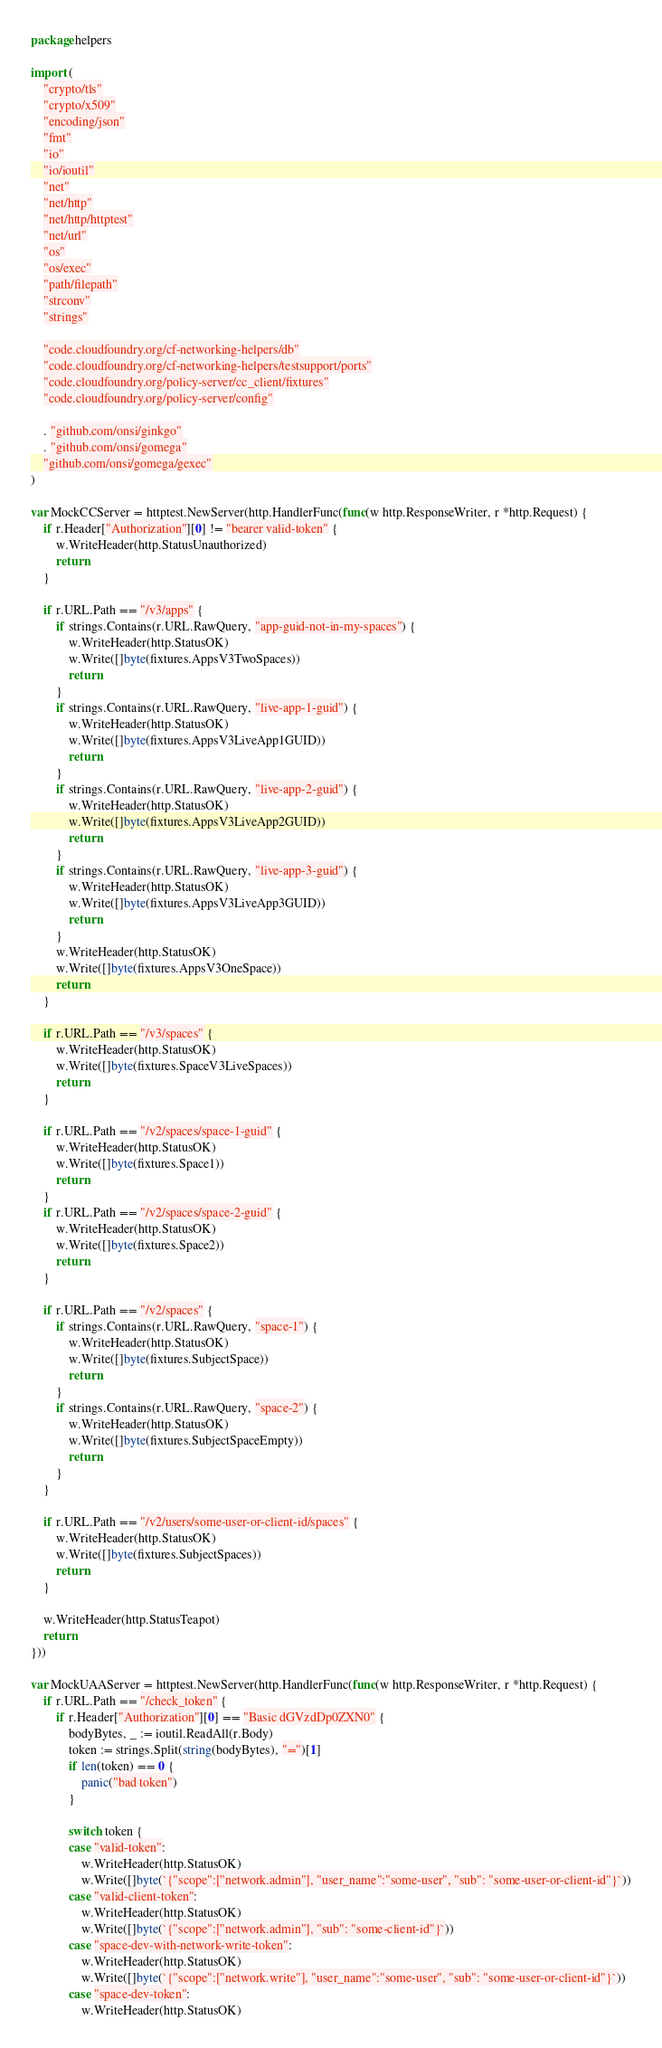<code> <loc_0><loc_0><loc_500><loc_500><_Go_>package helpers

import (
	"crypto/tls"
	"crypto/x509"
	"encoding/json"
	"fmt"
	"io"
	"io/ioutil"
	"net"
	"net/http"
	"net/http/httptest"
	"net/url"
	"os"
	"os/exec"
	"path/filepath"
	"strconv"
	"strings"

	"code.cloudfoundry.org/cf-networking-helpers/db"
	"code.cloudfoundry.org/cf-networking-helpers/testsupport/ports"
	"code.cloudfoundry.org/policy-server/cc_client/fixtures"
	"code.cloudfoundry.org/policy-server/config"

	. "github.com/onsi/ginkgo"
	. "github.com/onsi/gomega"
	"github.com/onsi/gomega/gexec"
)

var MockCCServer = httptest.NewServer(http.HandlerFunc(func(w http.ResponseWriter, r *http.Request) {
	if r.Header["Authorization"][0] != "bearer valid-token" {
		w.WriteHeader(http.StatusUnauthorized)
		return
	}

	if r.URL.Path == "/v3/apps" {
		if strings.Contains(r.URL.RawQuery, "app-guid-not-in-my-spaces") {
			w.WriteHeader(http.StatusOK)
			w.Write([]byte(fixtures.AppsV3TwoSpaces))
			return
		}
		if strings.Contains(r.URL.RawQuery, "live-app-1-guid") {
			w.WriteHeader(http.StatusOK)
			w.Write([]byte(fixtures.AppsV3LiveApp1GUID))
			return
		}
		if strings.Contains(r.URL.RawQuery, "live-app-2-guid") {
			w.WriteHeader(http.StatusOK)
			w.Write([]byte(fixtures.AppsV3LiveApp2GUID))
			return
		}
		if strings.Contains(r.URL.RawQuery, "live-app-3-guid") {
			w.WriteHeader(http.StatusOK)
			w.Write([]byte(fixtures.AppsV3LiveApp3GUID))
			return
		}
		w.WriteHeader(http.StatusOK)
		w.Write([]byte(fixtures.AppsV3OneSpace))
		return
	}

	if r.URL.Path == "/v3/spaces" {
		w.WriteHeader(http.StatusOK)
		w.Write([]byte(fixtures.SpaceV3LiveSpaces))
		return
	}

	if r.URL.Path == "/v2/spaces/space-1-guid" {
		w.WriteHeader(http.StatusOK)
		w.Write([]byte(fixtures.Space1))
		return
	}
	if r.URL.Path == "/v2/spaces/space-2-guid" {
		w.WriteHeader(http.StatusOK)
		w.Write([]byte(fixtures.Space2))
		return
	}

	if r.URL.Path == "/v2/spaces" {
		if strings.Contains(r.URL.RawQuery, "space-1") {
			w.WriteHeader(http.StatusOK)
			w.Write([]byte(fixtures.SubjectSpace))
			return
		}
		if strings.Contains(r.URL.RawQuery, "space-2") {
			w.WriteHeader(http.StatusOK)
			w.Write([]byte(fixtures.SubjectSpaceEmpty))
			return
		}
	}

	if r.URL.Path == "/v2/users/some-user-or-client-id/spaces" {
		w.WriteHeader(http.StatusOK)
		w.Write([]byte(fixtures.SubjectSpaces))
		return
	}

	w.WriteHeader(http.StatusTeapot)
	return
}))

var MockUAAServer = httptest.NewServer(http.HandlerFunc(func(w http.ResponseWriter, r *http.Request) {
	if r.URL.Path == "/check_token" {
		if r.Header["Authorization"][0] == "Basic dGVzdDp0ZXN0" {
			bodyBytes, _ := ioutil.ReadAll(r.Body)
			token := strings.Split(string(bodyBytes), "=")[1]
			if len(token) == 0 {
				panic("bad token")
			}

			switch token {
			case "valid-token":
				w.WriteHeader(http.StatusOK)
				w.Write([]byte(`{"scope":["network.admin"], "user_name":"some-user", "sub": "some-user-or-client-id"}`))
			case "valid-client-token":
				w.WriteHeader(http.StatusOK)
				w.Write([]byte(`{"scope":["network.admin"], "sub": "some-client-id"}`))
			case "space-dev-with-network-write-token":
				w.WriteHeader(http.StatusOK)
				w.Write([]byte(`{"scope":["network.write"], "user_name":"some-user", "sub": "some-user-or-client-id"}`))
			case "space-dev-token":
				w.WriteHeader(http.StatusOK)</code> 